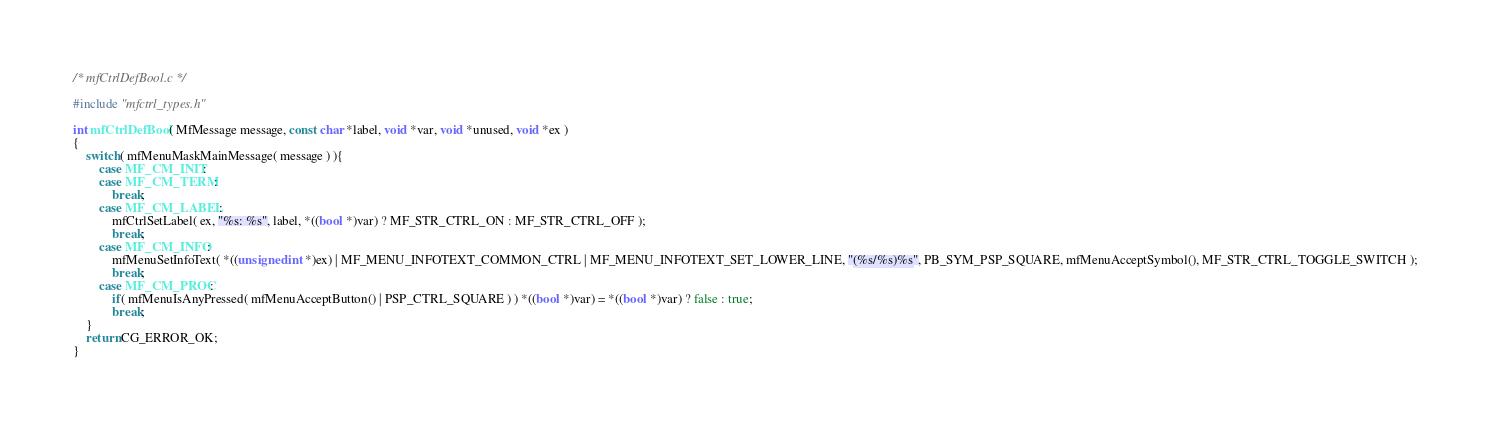<code> <loc_0><loc_0><loc_500><loc_500><_C_>/* mfCtrlDefBool.c */

#include "mfctrl_types.h"

int mfCtrlDefBool( MfMessage message, const char *label, void *var, void *unused, void *ex )
{
	switch( mfMenuMaskMainMessage( message ) ){
		case MF_CM_INIT:
		case MF_CM_TERM:
			break;
		case MF_CM_LABEL:
			mfCtrlSetLabel( ex, "%s: %s", label, *((bool *)var) ? MF_STR_CTRL_ON : MF_STR_CTRL_OFF );
			break;
		case MF_CM_INFO:
			mfMenuSetInfoText( *((unsigned int *)ex) | MF_MENU_INFOTEXT_COMMON_CTRL | MF_MENU_INFOTEXT_SET_LOWER_LINE, "(%s/%s)%s", PB_SYM_PSP_SQUARE, mfMenuAcceptSymbol(), MF_STR_CTRL_TOGGLE_SWITCH );
			break;
		case MF_CM_PROC:
			if( mfMenuIsAnyPressed( mfMenuAcceptButton() | PSP_CTRL_SQUARE ) ) *((bool *)var) = *((bool *)var) ? false : true;
			break;
	}
	return CG_ERROR_OK;
}
</code> 